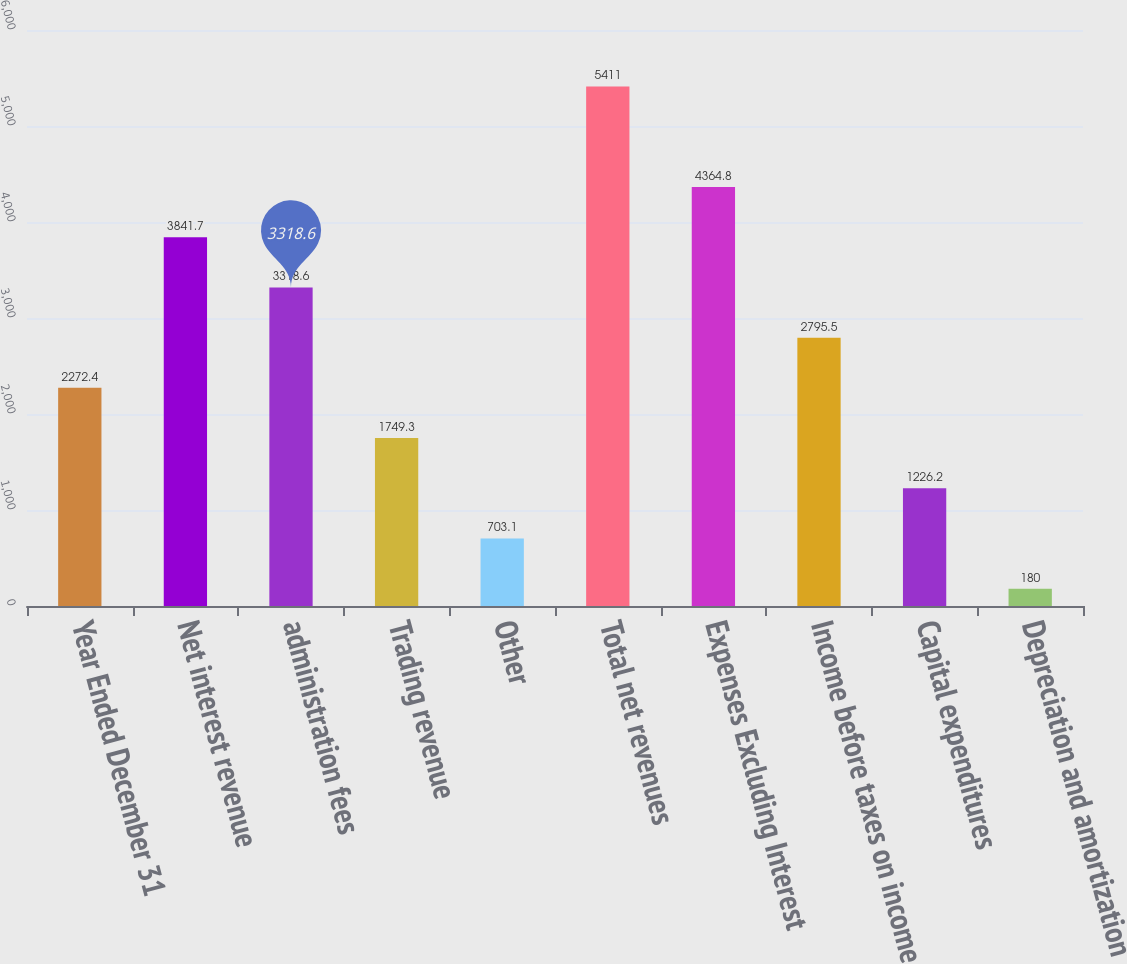<chart> <loc_0><loc_0><loc_500><loc_500><bar_chart><fcel>Year Ended December 31<fcel>Net interest revenue<fcel>administration fees<fcel>Trading revenue<fcel>Other<fcel>Total net revenues<fcel>Expenses Excluding Interest<fcel>Income before taxes on income<fcel>Capital expenditures<fcel>Depreciation and amortization<nl><fcel>2272.4<fcel>3841.7<fcel>3318.6<fcel>1749.3<fcel>703.1<fcel>5411<fcel>4364.8<fcel>2795.5<fcel>1226.2<fcel>180<nl></chart> 